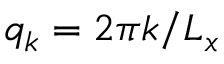<formula> <loc_0><loc_0><loc_500><loc_500>q _ { k } = 2 \pi k / L _ { x }</formula> 